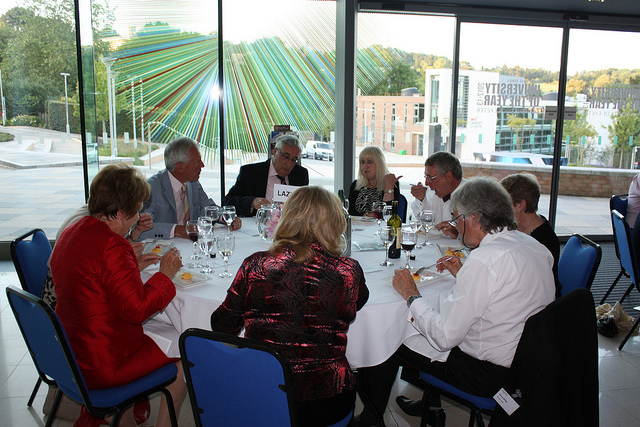Identify and read out the text in this image. LAZ UNIVERSITY OF THE YEAR 13 2015 THE YEAR UNIVERSITY 